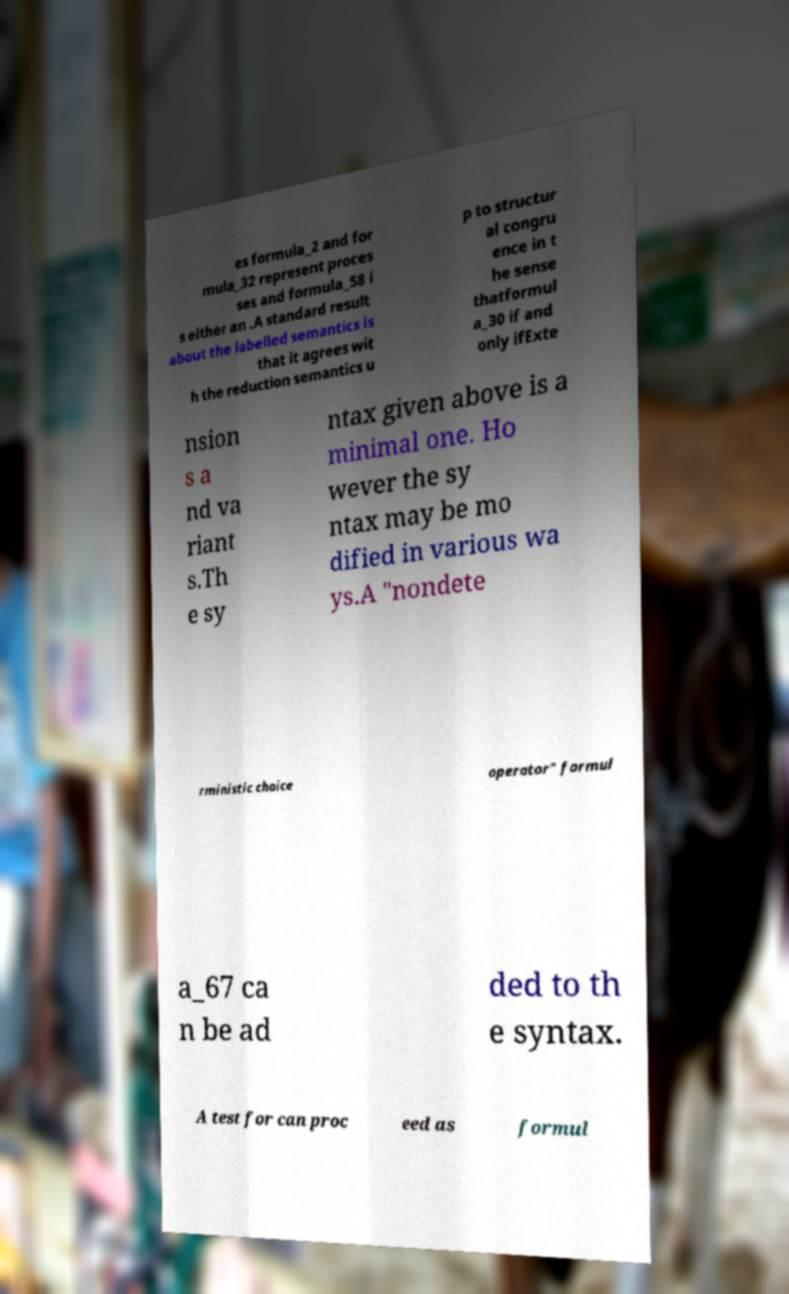Could you assist in decoding the text presented in this image and type it out clearly? es formula_2 and for mula_32 represent proces ses and formula_58 i s either an .A standard result about the labelled semantics is that it agrees wit h the reduction semantics u p to structur al congru ence in t he sense thatformul a_30 if and only ifExte nsion s a nd va riant s.Th e sy ntax given above is a minimal one. Ho wever the sy ntax may be mo dified in various wa ys.A "nondete rministic choice operator" formul a_67 ca n be ad ded to th e syntax. A test for can proc eed as formul 